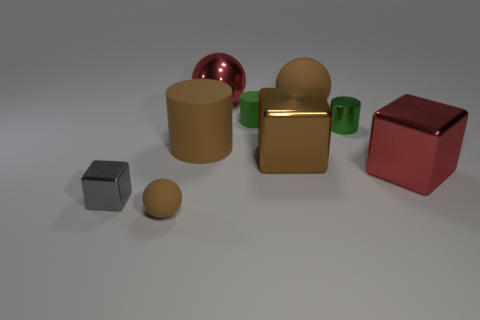Add 1 big red objects. How many objects exist? 10 Subtract all cylinders. How many objects are left? 6 Subtract all green shiny objects. Subtract all shiny cylinders. How many objects are left? 7 Add 3 big red blocks. How many big red blocks are left? 4 Add 1 large brown cubes. How many large brown cubes exist? 2 Subtract 2 brown balls. How many objects are left? 7 